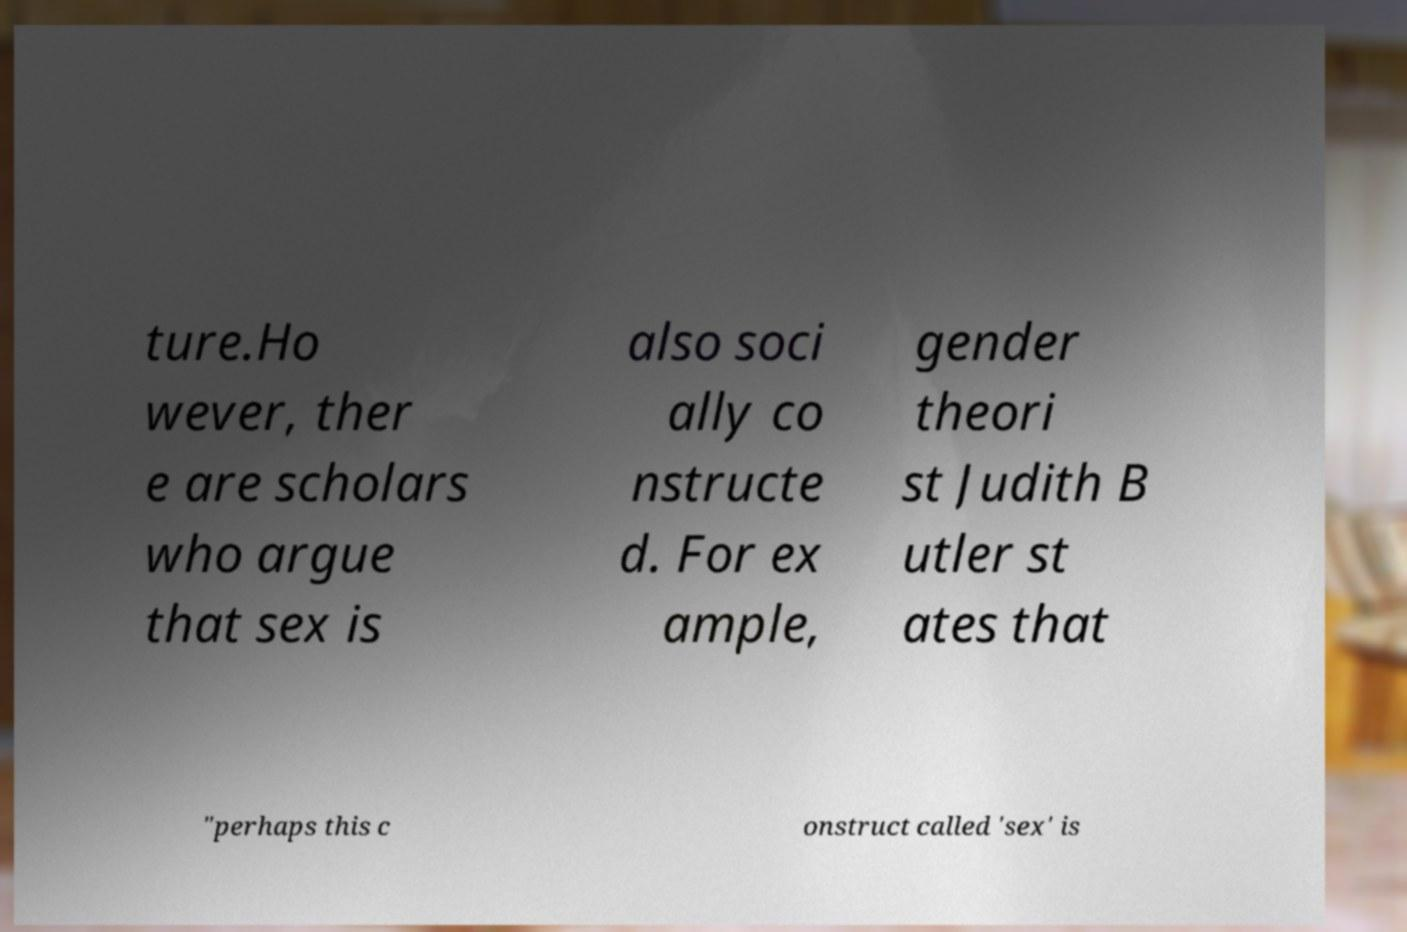What messages or text are displayed in this image? I need them in a readable, typed format. ture.Ho wever, ther e are scholars who argue that sex is also soci ally co nstructe d. For ex ample, gender theori st Judith B utler st ates that "perhaps this c onstruct called 'sex' is 